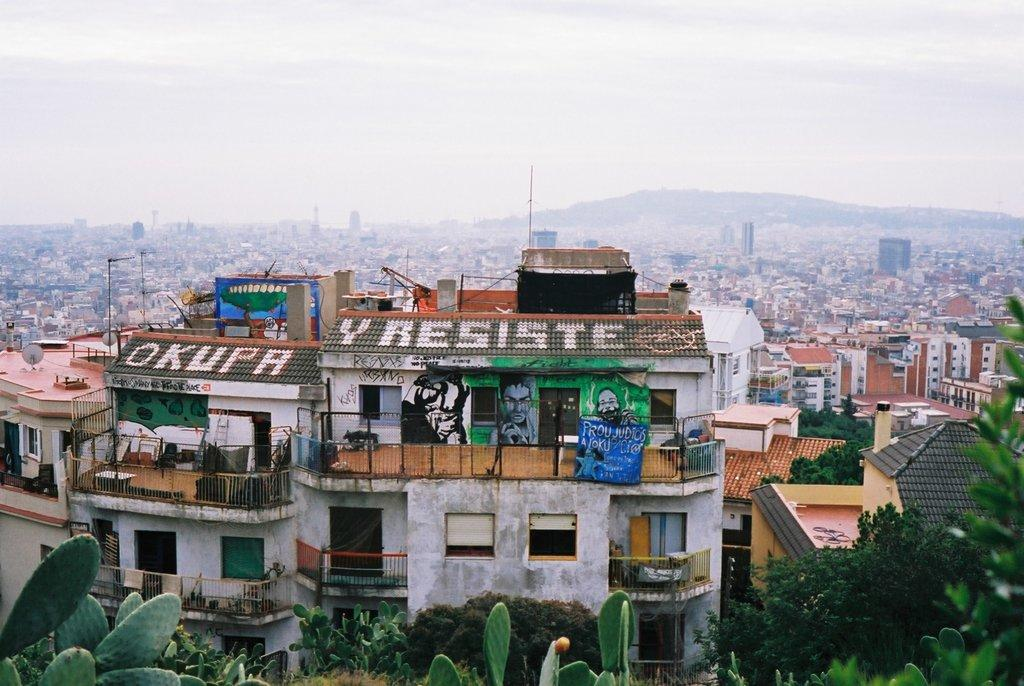What type of landscape is depicted in the image? The image contains a view of a city. What structures can be seen in the city? There are buildings in the image. Are there any natural elements present in the image? Yes, there are trees in the image. What can be seen in the distance in the image? There is a hill in the background of the image. What is visible above the city in the image? The sky is visible in the background of the image. What type of destruction can be seen happening to the brick buildings in the image? There is no destruction or brick buildings present in the image. 